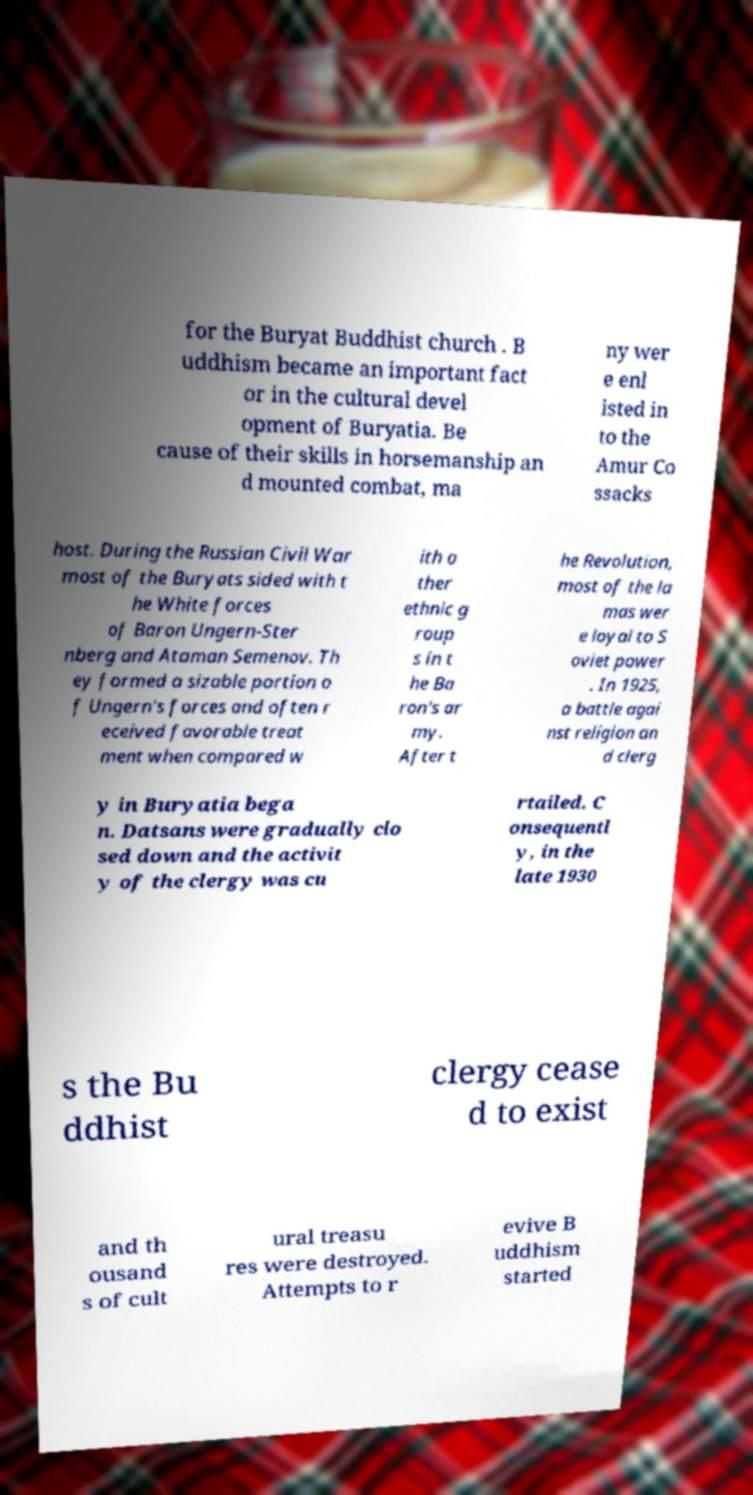Please identify and transcribe the text found in this image. for the Buryat Buddhist church . B uddhism became an important fact or in the cultural devel opment of Buryatia. Be cause of their skills in horsemanship an d mounted combat, ma ny wer e enl isted in to the Amur Co ssacks host. During the Russian Civil War most of the Buryats sided with t he White forces of Baron Ungern-Ster nberg and Ataman Semenov. Th ey formed a sizable portion o f Ungern's forces and often r eceived favorable treat ment when compared w ith o ther ethnic g roup s in t he Ba ron's ar my. After t he Revolution, most of the la mas wer e loyal to S oviet power . In 1925, a battle agai nst religion an d clerg y in Buryatia bega n. Datsans were gradually clo sed down and the activit y of the clergy was cu rtailed. C onsequentl y, in the late 1930 s the Bu ddhist clergy cease d to exist and th ousand s of cult ural treasu res were destroyed. Attempts to r evive B uddhism started 